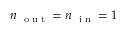Convert formula to latex. <formula><loc_0><loc_0><loc_500><loc_500>n _ { o u t } = n _ { i n } = 1</formula> 